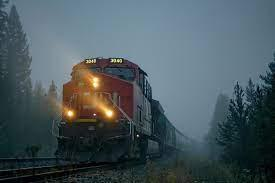How many unicorns are there in the image? There are no unicorns in the image. The image instead features a train moving along the tracks on what appears to be a foggy day, highlighting the powerful beauty of modern transportation juxtaposed with natural scenery. 